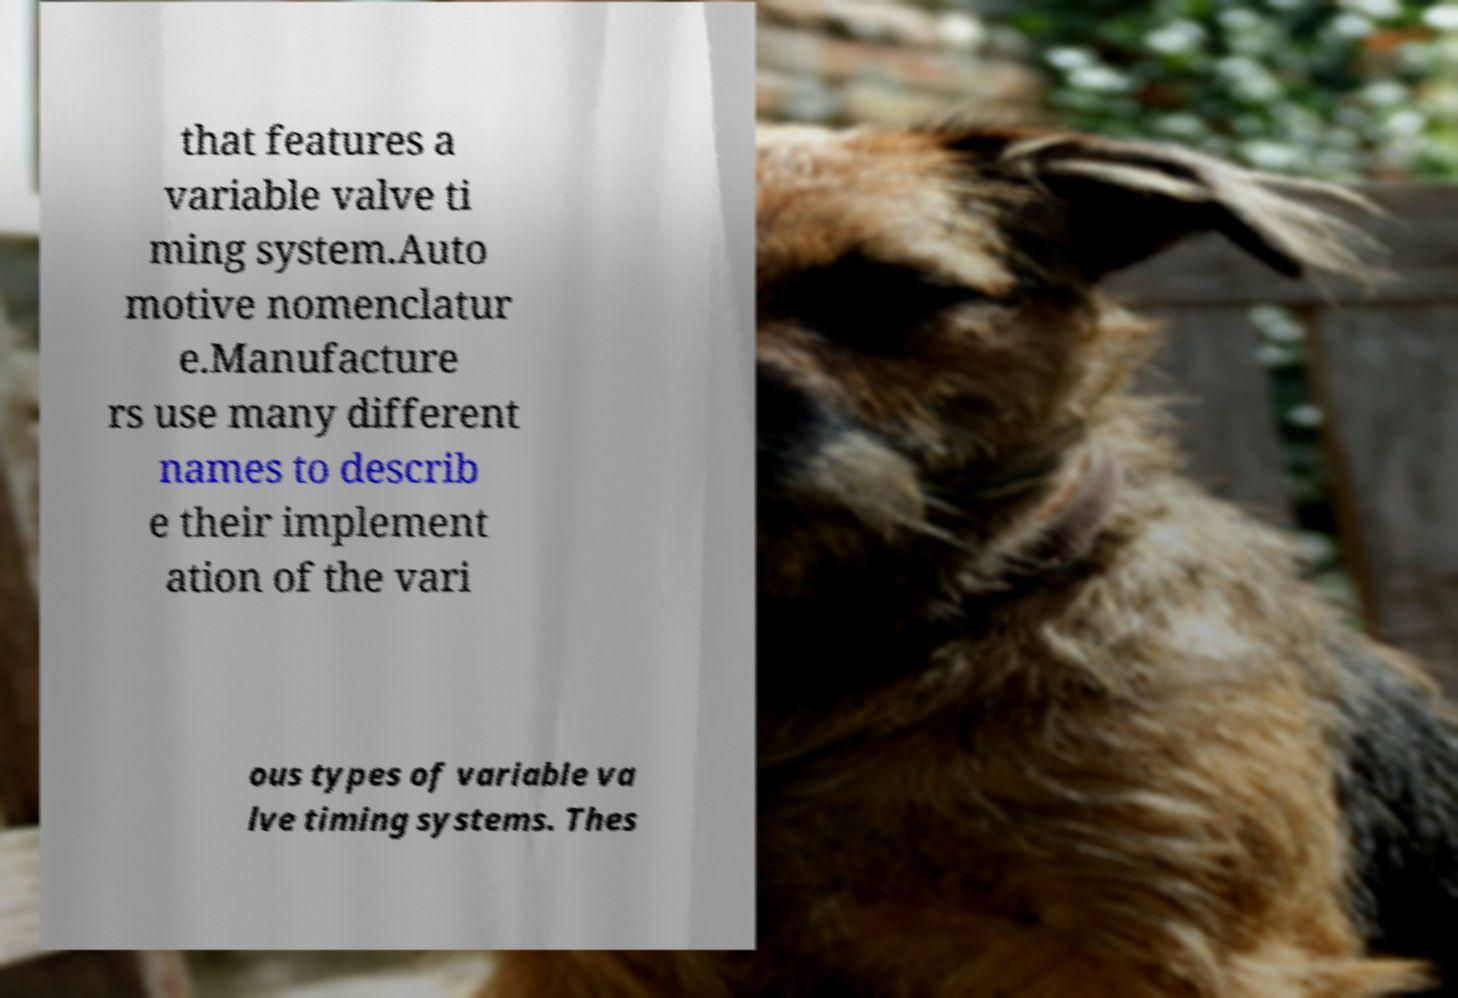Can you accurately transcribe the text from the provided image for me? that features a variable valve ti ming system.Auto motive nomenclatur e.Manufacture rs use many different names to describ e their implement ation of the vari ous types of variable va lve timing systems. Thes 